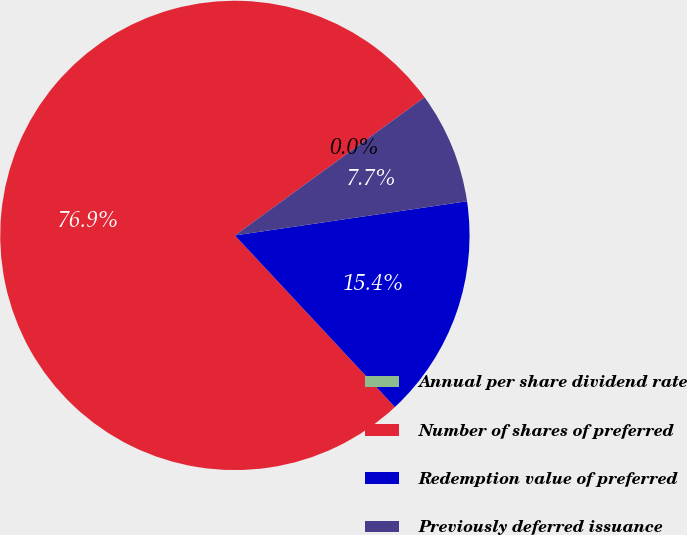Convert chart. <chart><loc_0><loc_0><loc_500><loc_500><pie_chart><fcel>Annual per share dividend rate<fcel>Number of shares of preferred<fcel>Redemption value of preferred<fcel>Previously deferred issuance<nl><fcel>0.0%<fcel>76.92%<fcel>15.38%<fcel>7.69%<nl></chart> 